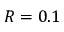Convert formula to latex. <formula><loc_0><loc_0><loc_500><loc_500>R = 0 . 1</formula> 